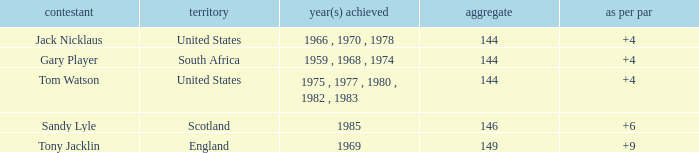What was Tom Watson's lowest To par when the total was larger than 144? None. Could you help me parse every detail presented in this table? {'header': ['contestant', 'territory', 'year(s) achieved', 'aggregate', 'as per par'], 'rows': [['Jack Nicklaus', 'United States', '1966 , 1970 , 1978', '144', '+4'], ['Gary Player', 'South Africa', '1959 , 1968 , 1974', '144', '+4'], ['Tom Watson', 'United States', '1975 , 1977 , 1980 , 1982 , 1983', '144', '+4'], ['Sandy Lyle', 'Scotland', '1985', '146', '+6'], ['Tony Jacklin', 'England', '1969', '149', '+9']]} 